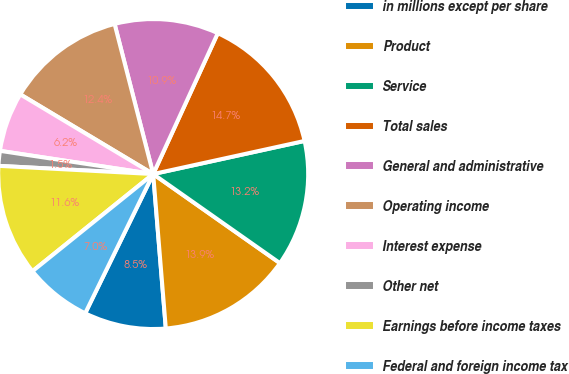<chart> <loc_0><loc_0><loc_500><loc_500><pie_chart><fcel>in millions except per share<fcel>Product<fcel>Service<fcel>Total sales<fcel>General and administrative<fcel>Operating income<fcel>Interest expense<fcel>Other net<fcel>Earnings before income taxes<fcel>Federal and foreign income tax<nl><fcel>8.53%<fcel>13.95%<fcel>13.18%<fcel>14.73%<fcel>10.85%<fcel>12.4%<fcel>6.2%<fcel>1.55%<fcel>11.63%<fcel>6.98%<nl></chart> 